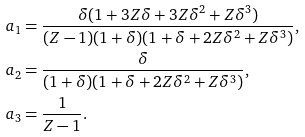Convert formula to latex. <formula><loc_0><loc_0><loc_500><loc_500>a _ { 1 } & = \frac { \delta ( 1 + 3 Z \delta + 3 Z \delta ^ { 2 } + Z \delta ^ { 3 } ) } { ( Z - 1 ) ( 1 + \delta ) ( 1 + \delta + 2 Z \delta ^ { 2 } + Z \delta ^ { 3 } ) } , \\ a _ { 2 } & = \frac { \delta } { ( 1 + \delta ) ( 1 + \delta + 2 Z \delta ^ { 2 } + Z \delta ^ { 3 } ) } , \\ a _ { 3 } & = \frac { 1 } { Z - 1 } .</formula> 